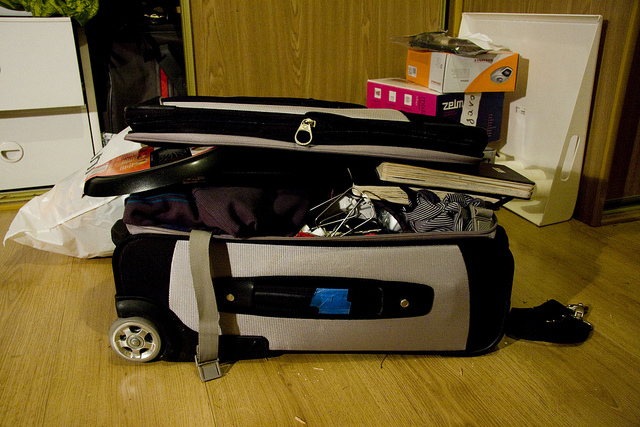Please transcribe the text in this image. ZPLM 